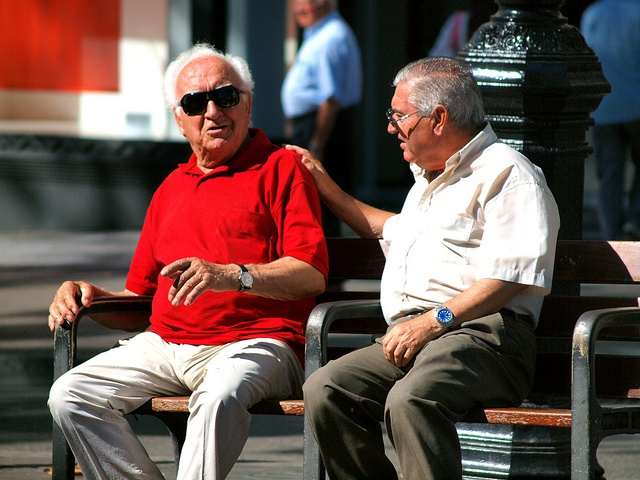Describe the objects in this image and their specific colors. I can see people in brown, red, black, white, and maroon tones, people in brown, black, white, gray, and darkgray tones, bench in brown, black, and gray tones, people in brown, black, lightblue, and blue tones, and clock in brown, black, lightgray, blue, and gray tones in this image. 